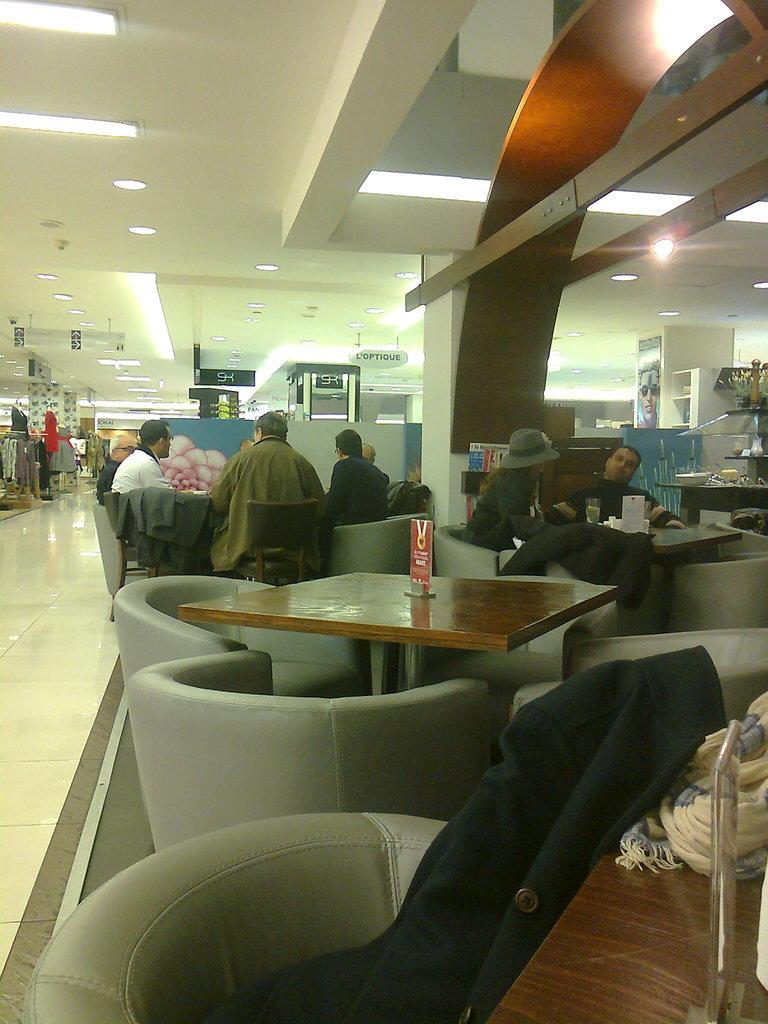Where was the photo taken? The photo was taken inside a mall. What are the people in the photo doing? People are sitting on chairs in the photo. What items can be seen on the table? There are clothes on a table in the photo. What is visible on the left side of the image? There are stores on the left side of the image. What type of lighting is present in the photo? There are lights on the ceiling in the photo. What type of letters can be seen on the train in the image? There are no trains or letters present in the image; it is taken inside a mall with people sitting on chairs and clothes on a table. What type of vase is visible on the right side of the image? There is no vase present in the image; it features a mall interior with people sitting on chairs, clothes on a table, stores on the left side, and lights on the ceiling. 